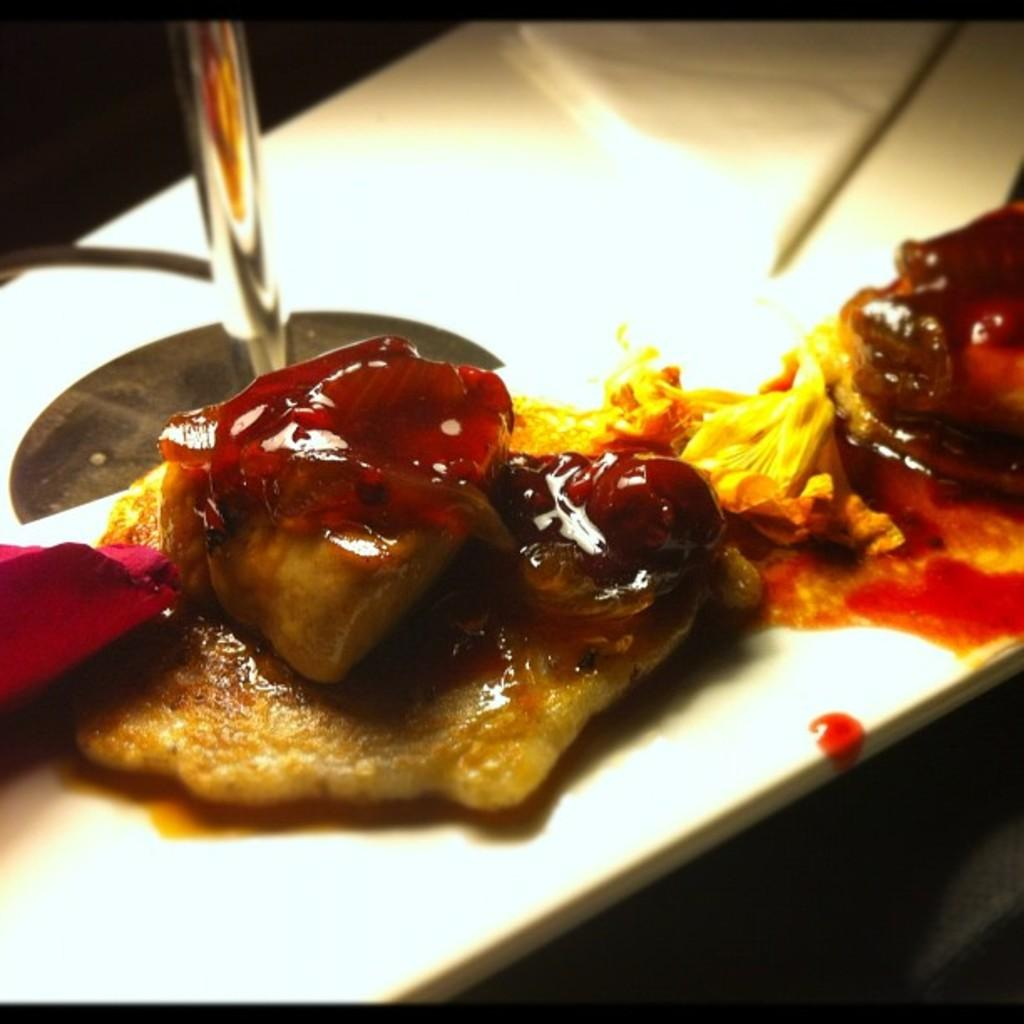What is on the plate that is visible in the image? There is food in a plate in the image. Where is the plate located in the image? The plate is placed on a table in the image. What type of industry is depicted in the image? There is no industry depicted in the image; it only shows a plate of food on a table. 